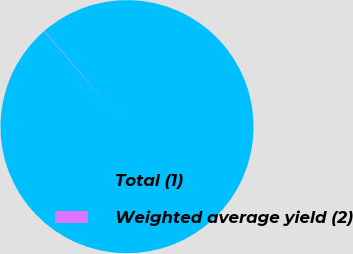Convert chart to OTSL. <chart><loc_0><loc_0><loc_500><loc_500><pie_chart><fcel>Total (1)<fcel>Weighted average yield (2)<nl><fcel>99.95%<fcel>0.05%<nl></chart> 